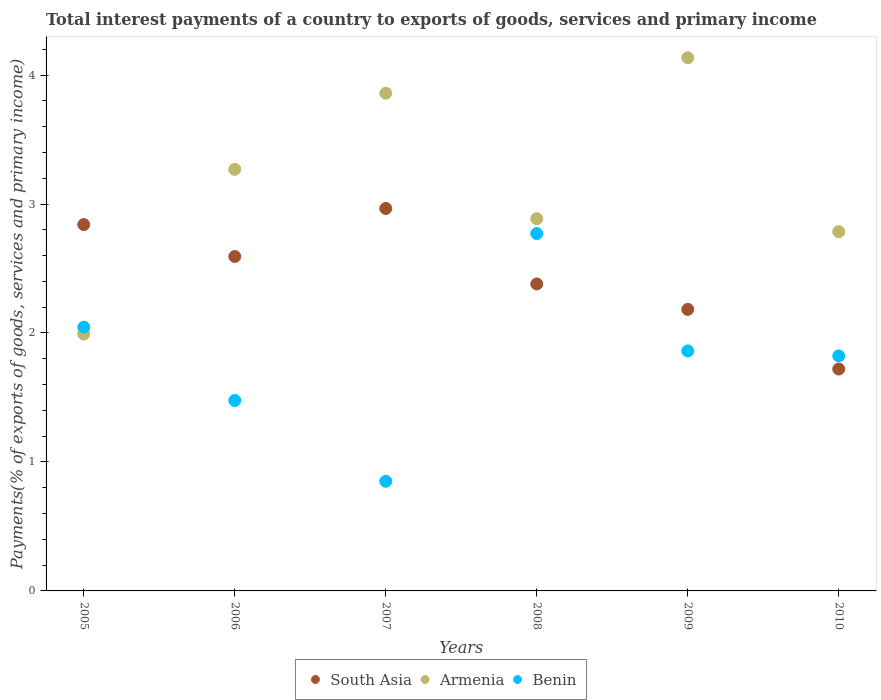What is the total interest payments in South Asia in 2006?
Provide a short and direct response. 2.59. Across all years, what is the maximum total interest payments in South Asia?
Give a very brief answer. 2.97. Across all years, what is the minimum total interest payments in Benin?
Provide a short and direct response. 0.85. In which year was the total interest payments in Armenia maximum?
Your answer should be compact. 2009. In which year was the total interest payments in Benin minimum?
Offer a very short reply. 2007. What is the total total interest payments in South Asia in the graph?
Provide a short and direct response. 14.68. What is the difference between the total interest payments in South Asia in 2009 and that in 2010?
Your answer should be very brief. 0.46. What is the difference between the total interest payments in South Asia in 2006 and the total interest payments in Benin in 2007?
Make the answer very short. 1.74. What is the average total interest payments in South Asia per year?
Provide a short and direct response. 2.45. In the year 2008, what is the difference between the total interest payments in South Asia and total interest payments in Benin?
Ensure brevity in your answer.  -0.39. What is the ratio of the total interest payments in Armenia in 2007 to that in 2010?
Give a very brief answer. 1.39. Is the total interest payments in Armenia in 2006 less than that in 2008?
Offer a very short reply. No. What is the difference between the highest and the second highest total interest payments in Benin?
Provide a short and direct response. 0.73. What is the difference between the highest and the lowest total interest payments in South Asia?
Give a very brief answer. 1.25. In how many years, is the total interest payments in Armenia greater than the average total interest payments in Armenia taken over all years?
Offer a very short reply. 3. Is the sum of the total interest payments in Benin in 2007 and 2008 greater than the maximum total interest payments in Armenia across all years?
Your answer should be very brief. No. Is it the case that in every year, the sum of the total interest payments in Benin and total interest payments in Armenia  is greater than the total interest payments in South Asia?
Provide a succinct answer. Yes. Is the total interest payments in South Asia strictly greater than the total interest payments in Armenia over the years?
Provide a short and direct response. No. How many dotlines are there?
Your answer should be very brief. 3. How many years are there in the graph?
Provide a short and direct response. 6. Are the values on the major ticks of Y-axis written in scientific E-notation?
Your answer should be very brief. No. Does the graph contain any zero values?
Your answer should be compact. No. How are the legend labels stacked?
Offer a terse response. Horizontal. What is the title of the graph?
Offer a very short reply. Total interest payments of a country to exports of goods, services and primary income. Does "Zambia" appear as one of the legend labels in the graph?
Your response must be concise. No. What is the label or title of the X-axis?
Give a very brief answer. Years. What is the label or title of the Y-axis?
Provide a short and direct response. Payments(% of exports of goods, services and primary income). What is the Payments(% of exports of goods, services and primary income) in South Asia in 2005?
Your answer should be very brief. 2.84. What is the Payments(% of exports of goods, services and primary income) of Armenia in 2005?
Offer a terse response. 1.99. What is the Payments(% of exports of goods, services and primary income) of Benin in 2005?
Your response must be concise. 2.05. What is the Payments(% of exports of goods, services and primary income) of South Asia in 2006?
Provide a short and direct response. 2.59. What is the Payments(% of exports of goods, services and primary income) in Armenia in 2006?
Offer a terse response. 3.27. What is the Payments(% of exports of goods, services and primary income) of Benin in 2006?
Provide a succinct answer. 1.48. What is the Payments(% of exports of goods, services and primary income) in South Asia in 2007?
Ensure brevity in your answer.  2.97. What is the Payments(% of exports of goods, services and primary income) of Armenia in 2007?
Offer a terse response. 3.86. What is the Payments(% of exports of goods, services and primary income) in Benin in 2007?
Your answer should be very brief. 0.85. What is the Payments(% of exports of goods, services and primary income) of South Asia in 2008?
Keep it short and to the point. 2.38. What is the Payments(% of exports of goods, services and primary income) in Armenia in 2008?
Offer a terse response. 2.89. What is the Payments(% of exports of goods, services and primary income) of Benin in 2008?
Provide a short and direct response. 2.77. What is the Payments(% of exports of goods, services and primary income) of South Asia in 2009?
Your response must be concise. 2.18. What is the Payments(% of exports of goods, services and primary income) of Armenia in 2009?
Provide a short and direct response. 4.13. What is the Payments(% of exports of goods, services and primary income) in Benin in 2009?
Your answer should be very brief. 1.86. What is the Payments(% of exports of goods, services and primary income) of South Asia in 2010?
Give a very brief answer. 1.72. What is the Payments(% of exports of goods, services and primary income) in Armenia in 2010?
Give a very brief answer. 2.79. What is the Payments(% of exports of goods, services and primary income) in Benin in 2010?
Make the answer very short. 1.82. Across all years, what is the maximum Payments(% of exports of goods, services and primary income) in South Asia?
Keep it short and to the point. 2.97. Across all years, what is the maximum Payments(% of exports of goods, services and primary income) of Armenia?
Provide a short and direct response. 4.13. Across all years, what is the maximum Payments(% of exports of goods, services and primary income) of Benin?
Your answer should be very brief. 2.77. Across all years, what is the minimum Payments(% of exports of goods, services and primary income) of South Asia?
Offer a terse response. 1.72. Across all years, what is the minimum Payments(% of exports of goods, services and primary income) of Armenia?
Ensure brevity in your answer.  1.99. Across all years, what is the minimum Payments(% of exports of goods, services and primary income) in Benin?
Your answer should be very brief. 0.85. What is the total Payments(% of exports of goods, services and primary income) in South Asia in the graph?
Your answer should be compact. 14.68. What is the total Payments(% of exports of goods, services and primary income) in Armenia in the graph?
Provide a succinct answer. 18.93. What is the total Payments(% of exports of goods, services and primary income) of Benin in the graph?
Offer a very short reply. 10.83. What is the difference between the Payments(% of exports of goods, services and primary income) in South Asia in 2005 and that in 2006?
Your answer should be compact. 0.25. What is the difference between the Payments(% of exports of goods, services and primary income) of Armenia in 2005 and that in 2006?
Your response must be concise. -1.28. What is the difference between the Payments(% of exports of goods, services and primary income) in Benin in 2005 and that in 2006?
Your answer should be very brief. 0.57. What is the difference between the Payments(% of exports of goods, services and primary income) in South Asia in 2005 and that in 2007?
Offer a very short reply. -0.12. What is the difference between the Payments(% of exports of goods, services and primary income) in Armenia in 2005 and that in 2007?
Your answer should be compact. -1.87. What is the difference between the Payments(% of exports of goods, services and primary income) of Benin in 2005 and that in 2007?
Ensure brevity in your answer.  1.19. What is the difference between the Payments(% of exports of goods, services and primary income) of South Asia in 2005 and that in 2008?
Provide a short and direct response. 0.46. What is the difference between the Payments(% of exports of goods, services and primary income) of Armenia in 2005 and that in 2008?
Provide a short and direct response. -0.9. What is the difference between the Payments(% of exports of goods, services and primary income) in Benin in 2005 and that in 2008?
Provide a short and direct response. -0.73. What is the difference between the Payments(% of exports of goods, services and primary income) of South Asia in 2005 and that in 2009?
Provide a succinct answer. 0.66. What is the difference between the Payments(% of exports of goods, services and primary income) in Armenia in 2005 and that in 2009?
Keep it short and to the point. -2.14. What is the difference between the Payments(% of exports of goods, services and primary income) of Benin in 2005 and that in 2009?
Offer a very short reply. 0.18. What is the difference between the Payments(% of exports of goods, services and primary income) of South Asia in 2005 and that in 2010?
Your response must be concise. 1.12. What is the difference between the Payments(% of exports of goods, services and primary income) of Armenia in 2005 and that in 2010?
Offer a terse response. -0.79. What is the difference between the Payments(% of exports of goods, services and primary income) of Benin in 2005 and that in 2010?
Your answer should be very brief. 0.22. What is the difference between the Payments(% of exports of goods, services and primary income) of South Asia in 2006 and that in 2007?
Offer a very short reply. -0.37. What is the difference between the Payments(% of exports of goods, services and primary income) of Armenia in 2006 and that in 2007?
Provide a short and direct response. -0.59. What is the difference between the Payments(% of exports of goods, services and primary income) in Benin in 2006 and that in 2007?
Offer a terse response. 0.63. What is the difference between the Payments(% of exports of goods, services and primary income) in South Asia in 2006 and that in 2008?
Your answer should be very brief. 0.21. What is the difference between the Payments(% of exports of goods, services and primary income) in Armenia in 2006 and that in 2008?
Give a very brief answer. 0.38. What is the difference between the Payments(% of exports of goods, services and primary income) of Benin in 2006 and that in 2008?
Ensure brevity in your answer.  -1.29. What is the difference between the Payments(% of exports of goods, services and primary income) in South Asia in 2006 and that in 2009?
Offer a terse response. 0.41. What is the difference between the Payments(% of exports of goods, services and primary income) of Armenia in 2006 and that in 2009?
Offer a very short reply. -0.87. What is the difference between the Payments(% of exports of goods, services and primary income) in Benin in 2006 and that in 2009?
Keep it short and to the point. -0.38. What is the difference between the Payments(% of exports of goods, services and primary income) in South Asia in 2006 and that in 2010?
Provide a succinct answer. 0.87. What is the difference between the Payments(% of exports of goods, services and primary income) of Armenia in 2006 and that in 2010?
Keep it short and to the point. 0.48. What is the difference between the Payments(% of exports of goods, services and primary income) of Benin in 2006 and that in 2010?
Your response must be concise. -0.35. What is the difference between the Payments(% of exports of goods, services and primary income) in South Asia in 2007 and that in 2008?
Make the answer very short. 0.59. What is the difference between the Payments(% of exports of goods, services and primary income) of Armenia in 2007 and that in 2008?
Offer a terse response. 0.97. What is the difference between the Payments(% of exports of goods, services and primary income) in Benin in 2007 and that in 2008?
Provide a short and direct response. -1.92. What is the difference between the Payments(% of exports of goods, services and primary income) in South Asia in 2007 and that in 2009?
Offer a terse response. 0.78. What is the difference between the Payments(% of exports of goods, services and primary income) of Armenia in 2007 and that in 2009?
Your response must be concise. -0.28. What is the difference between the Payments(% of exports of goods, services and primary income) in Benin in 2007 and that in 2009?
Provide a succinct answer. -1.01. What is the difference between the Payments(% of exports of goods, services and primary income) of South Asia in 2007 and that in 2010?
Your answer should be very brief. 1.25. What is the difference between the Payments(% of exports of goods, services and primary income) of Armenia in 2007 and that in 2010?
Give a very brief answer. 1.07. What is the difference between the Payments(% of exports of goods, services and primary income) in Benin in 2007 and that in 2010?
Keep it short and to the point. -0.97. What is the difference between the Payments(% of exports of goods, services and primary income) of South Asia in 2008 and that in 2009?
Your answer should be compact. 0.2. What is the difference between the Payments(% of exports of goods, services and primary income) of Armenia in 2008 and that in 2009?
Give a very brief answer. -1.25. What is the difference between the Payments(% of exports of goods, services and primary income) of Benin in 2008 and that in 2009?
Your answer should be very brief. 0.91. What is the difference between the Payments(% of exports of goods, services and primary income) in South Asia in 2008 and that in 2010?
Give a very brief answer. 0.66. What is the difference between the Payments(% of exports of goods, services and primary income) in Armenia in 2008 and that in 2010?
Keep it short and to the point. 0.1. What is the difference between the Payments(% of exports of goods, services and primary income) of Benin in 2008 and that in 2010?
Offer a terse response. 0.95. What is the difference between the Payments(% of exports of goods, services and primary income) of South Asia in 2009 and that in 2010?
Offer a very short reply. 0.46. What is the difference between the Payments(% of exports of goods, services and primary income) in Armenia in 2009 and that in 2010?
Offer a terse response. 1.35. What is the difference between the Payments(% of exports of goods, services and primary income) of Benin in 2009 and that in 2010?
Provide a succinct answer. 0.04. What is the difference between the Payments(% of exports of goods, services and primary income) in South Asia in 2005 and the Payments(% of exports of goods, services and primary income) in Armenia in 2006?
Provide a succinct answer. -0.43. What is the difference between the Payments(% of exports of goods, services and primary income) of South Asia in 2005 and the Payments(% of exports of goods, services and primary income) of Benin in 2006?
Keep it short and to the point. 1.36. What is the difference between the Payments(% of exports of goods, services and primary income) in Armenia in 2005 and the Payments(% of exports of goods, services and primary income) in Benin in 2006?
Your answer should be compact. 0.51. What is the difference between the Payments(% of exports of goods, services and primary income) in South Asia in 2005 and the Payments(% of exports of goods, services and primary income) in Armenia in 2007?
Give a very brief answer. -1.02. What is the difference between the Payments(% of exports of goods, services and primary income) in South Asia in 2005 and the Payments(% of exports of goods, services and primary income) in Benin in 2007?
Keep it short and to the point. 1.99. What is the difference between the Payments(% of exports of goods, services and primary income) of Armenia in 2005 and the Payments(% of exports of goods, services and primary income) of Benin in 2007?
Your answer should be compact. 1.14. What is the difference between the Payments(% of exports of goods, services and primary income) of South Asia in 2005 and the Payments(% of exports of goods, services and primary income) of Armenia in 2008?
Offer a terse response. -0.05. What is the difference between the Payments(% of exports of goods, services and primary income) in South Asia in 2005 and the Payments(% of exports of goods, services and primary income) in Benin in 2008?
Your response must be concise. 0.07. What is the difference between the Payments(% of exports of goods, services and primary income) of Armenia in 2005 and the Payments(% of exports of goods, services and primary income) of Benin in 2008?
Make the answer very short. -0.78. What is the difference between the Payments(% of exports of goods, services and primary income) in South Asia in 2005 and the Payments(% of exports of goods, services and primary income) in Armenia in 2009?
Offer a terse response. -1.29. What is the difference between the Payments(% of exports of goods, services and primary income) in South Asia in 2005 and the Payments(% of exports of goods, services and primary income) in Benin in 2009?
Ensure brevity in your answer.  0.98. What is the difference between the Payments(% of exports of goods, services and primary income) in Armenia in 2005 and the Payments(% of exports of goods, services and primary income) in Benin in 2009?
Give a very brief answer. 0.13. What is the difference between the Payments(% of exports of goods, services and primary income) in South Asia in 2005 and the Payments(% of exports of goods, services and primary income) in Armenia in 2010?
Your answer should be compact. 0.05. What is the difference between the Payments(% of exports of goods, services and primary income) in South Asia in 2005 and the Payments(% of exports of goods, services and primary income) in Benin in 2010?
Keep it short and to the point. 1.02. What is the difference between the Payments(% of exports of goods, services and primary income) of Armenia in 2005 and the Payments(% of exports of goods, services and primary income) of Benin in 2010?
Offer a terse response. 0.17. What is the difference between the Payments(% of exports of goods, services and primary income) in South Asia in 2006 and the Payments(% of exports of goods, services and primary income) in Armenia in 2007?
Your answer should be very brief. -1.27. What is the difference between the Payments(% of exports of goods, services and primary income) of South Asia in 2006 and the Payments(% of exports of goods, services and primary income) of Benin in 2007?
Provide a short and direct response. 1.74. What is the difference between the Payments(% of exports of goods, services and primary income) of Armenia in 2006 and the Payments(% of exports of goods, services and primary income) of Benin in 2007?
Your answer should be very brief. 2.42. What is the difference between the Payments(% of exports of goods, services and primary income) of South Asia in 2006 and the Payments(% of exports of goods, services and primary income) of Armenia in 2008?
Give a very brief answer. -0.29. What is the difference between the Payments(% of exports of goods, services and primary income) of South Asia in 2006 and the Payments(% of exports of goods, services and primary income) of Benin in 2008?
Your answer should be very brief. -0.18. What is the difference between the Payments(% of exports of goods, services and primary income) in Armenia in 2006 and the Payments(% of exports of goods, services and primary income) in Benin in 2008?
Your answer should be very brief. 0.5. What is the difference between the Payments(% of exports of goods, services and primary income) in South Asia in 2006 and the Payments(% of exports of goods, services and primary income) in Armenia in 2009?
Offer a terse response. -1.54. What is the difference between the Payments(% of exports of goods, services and primary income) in South Asia in 2006 and the Payments(% of exports of goods, services and primary income) in Benin in 2009?
Keep it short and to the point. 0.73. What is the difference between the Payments(% of exports of goods, services and primary income) in Armenia in 2006 and the Payments(% of exports of goods, services and primary income) in Benin in 2009?
Your answer should be compact. 1.41. What is the difference between the Payments(% of exports of goods, services and primary income) of South Asia in 2006 and the Payments(% of exports of goods, services and primary income) of Armenia in 2010?
Your answer should be compact. -0.19. What is the difference between the Payments(% of exports of goods, services and primary income) in South Asia in 2006 and the Payments(% of exports of goods, services and primary income) in Benin in 2010?
Ensure brevity in your answer.  0.77. What is the difference between the Payments(% of exports of goods, services and primary income) in Armenia in 2006 and the Payments(% of exports of goods, services and primary income) in Benin in 2010?
Ensure brevity in your answer.  1.45. What is the difference between the Payments(% of exports of goods, services and primary income) of South Asia in 2007 and the Payments(% of exports of goods, services and primary income) of Armenia in 2008?
Make the answer very short. 0.08. What is the difference between the Payments(% of exports of goods, services and primary income) of South Asia in 2007 and the Payments(% of exports of goods, services and primary income) of Benin in 2008?
Provide a succinct answer. 0.19. What is the difference between the Payments(% of exports of goods, services and primary income) of Armenia in 2007 and the Payments(% of exports of goods, services and primary income) of Benin in 2008?
Provide a short and direct response. 1.09. What is the difference between the Payments(% of exports of goods, services and primary income) in South Asia in 2007 and the Payments(% of exports of goods, services and primary income) in Armenia in 2009?
Offer a very short reply. -1.17. What is the difference between the Payments(% of exports of goods, services and primary income) in South Asia in 2007 and the Payments(% of exports of goods, services and primary income) in Benin in 2009?
Make the answer very short. 1.1. What is the difference between the Payments(% of exports of goods, services and primary income) in Armenia in 2007 and the Payments(% of exports of goods, services and primary income) in Benin in 2009?
Provide a succinct answer. 2. What is the difference between the Payments(% of exports of goods, services and primary income) in South Asia in 2007 and the Payments(% of exports of goods, services and primary income) in Armenia in 2010?
Give a very brief answer. 0.18. What is the difference between the Payments(% of exports of goods, services and primary income) of South Asia in 2007 and the Payments(% of exports of goods, services and primary income) of Benin in 2010?
Your response must be concise. 1.14. What is the difference between the Payments(% of exports of goods, services and primary income) in Armenia in 2007 and the Payments(% of exports of goods, services and primary income) in Benin in 2010?
Offer a very short reply. 2.04. What is the difference between the Payments(% of exports of goods, services and primary income) of South Asia in 2008 and the Payments(% of exports of goods, services and primary income) of Armenia in 2009?
Ensure brevity in your answer.  -1.75. What is the difference between the Payments(% of exports of goods, services and primary income) in South Asia in 2008 and the Payments(% of exports of goods, services and primary income) in Benin in 2009?
Provide a succinct answer. 0.52. What is the difference between the Payments(% of exports of goods, services and primary income) in Armenia in 2008 and the Payments(% of exports of goods, services and primary income) in Benin in 2009?
Offer a terse response. 1.03. What is the difference between the Payments(% of exports of goods, services and primary income) in South Asia in 2008 and the Payments(% of exports of goods, services and primary income) in Armenia in 2010?
Provide a short and direct response. -0.41. What is the difference between the Payments(% of exports of goods, services and primary income) in South Asia in 2008 and the Payments(% of exports of goods, services and primary income) in Benin in 2010?
Keep it short and to the point. 0.56. What is the difference between the Payments(% of exports of goods, services and primary income) in Armenia in 2008 and the Payments(% of exports of goods, services and primary income) in Benin in 2010?
Your response must be concise. 1.06. What is the difference between the Payments(% of exports of goods, services and primary income) of South Asia in 2009 and the Payments(% of exports of goods, services and primary income) of Armenia in 2010?
Provide a short and direct response. -0.6. What is the difference between the Payments(% of exports of goods, services and primary income) of South Asia in 2009 and the Payments(% of exports of goods, services and primary income) of Benin in 2010?
Your response must be concise. 0.36. What is the difference between the Payments(% of exports of goods, services and primary income) of Armenia in 2009 and the Payments(% of exports of goods, services and primary income) of Benin in 2010?
Make the answer very short. 2.31. What is the average Payments(% of exports of goods, services and primary income) in South Asia per year?
Give a very brief answer. 2.45. What is the average Payments(% of exports of goods, services and primary income) in Armenia per year?
Give a very brief answer. 3.15. What is the average Payments(% of exports of goods, services and primary income) of Benin per year?
Ensure brevity in your answer.  1.8. In the year 2005, what is the difference between the Payments(% of exports of goods, services and primary income) in South Asia and Payments(% of exports of goods, services and primary income) in Armenia?
Your response must be concise. 0.85. In the year 2005, what is the difference between the Payments(% of exports of goods, services and primary income) of South Asia and Payments(% of exports of goods, services and primary income) of Benin?
Ensure brevity in your answer.  0.8. In the year 2005, what is the difference between the Payments(% of exports of goods, services and primary income) in Armenia and Payments(% of exports of goods, services and primary income) in Benin?
Your answer should be compact. -0.05. In the year 2006, what is the difference between the Payments(% of exports of goods, services and primary income) in South Asia and Payments(% of exports of goods, services and primary income) in Armenia?
Offer a terse response. -0.68. In the year 2006, what is the difference between the Payments(% of exports of goods, services and primary income) of South Asia and Payments(% of exports of goods, services and primary income) of Benin?
Give a very brief answer. 1.12. In the year 2006, what is the difference between the Payments(% of exports of goods, services and primary income) of Armenia and Payments(% of exports of goods, services and primary income) of Benin?
Your answer should be very brief. 1.79. In the year 2007, what is the difference between the Payments(% of exports of goods, services and primary income) of South Asia and Payments(% of exports of goods, services and primary income) of Armenia?
Offer a very short reply. -0.89. In the year 2007, what is the difference between the Payments(% of exports of goods, services and primary income) of South Asia and Payments(% of exports of goods, services and primary income) of Benin?
Offer a terse response. 2.12. In the year 2007, what is the difference between the Payments(% of exports of goods, services and primary income) of Armenia and Payments(% of exports of goods, services and primary income) of Benin?
Your answer should be compact. 3.01. In the year 2008, what is the difference between the Payments(% of exports of goods, services and primary income) in South Asia and Payments(% of exports of goods, services and primary income) in Armenia?
Your response must be concise. -0.51. In the year 2008, what is the difference between the Payments(% of exports of goods, services and primary income) of South Asia and Payments(% of exports of goods, services and primary income) of Benin?
Offer a very short reply. -0.39. In the year 2008, what is the difference between the Payments(% of exports of goods, services and primary income) of Armenia and Payments(% of exports of goods, services and primary income) of Benin?
Give a very brief answer. 0.12. In the year 2009, what is the difference between the Payments(% of exports of goods, services and primary income) of South Asia and Payments(% of exports of goods, services and primary income) of Armenia?
Your answer should be compact. -1.95. In the year 2009, what is the difference between the Payments(% of exports of goods, services and primary income) of South Asia and Payments(% of exports of goods, services and primary income) of Benin?
Your response must be concise. 0.32. In the year 2009, what is the difference between the Payments(% of exports of goods, services and primary income) of Armenia and Payments(% of exports of goods, services and primary income) of Benin?
Your answer should be compact. 2.27. In the year 2010, what is the difference between the Payments(% of exports of goods, services and primary income) in South Asia and Payments(% of exports of goods, services and primary income) in Armenia?
Provide a succinct answer. -1.07. In the year 2010, what is the difference between the Payments(% of exports of goods, services and primary income) of South Asia and Payments(% of exports of goods, services and primary income) of Benin?
Your response must be concise. -0.1. In the year 2010, what is the difference between the Payments(% of exports of goods, services and primary income) of Armenia and Payments(% of exports of goods, services and primary income) of Benin?
Your answer should be compact. 0.96. What is the ratio of the Payments(% of exports of goods, services and primary income) in South Asia in 2005 to that in 2006?
Provide a short and direct response. 1.1. What is the ratio of the Payments(% of exports of goods, services and primary income) of Armenia in 2005 to that in 2006?
Make the answer very short. 0.61. What is the ratio of the Payments(% of exports of goods, services and primary income) of Benin in 2005 to that in 2006?
Offer a very short reply. 1.38. What is the ratio of the Payments(% of exports of goods, services and primary income) of South Asia in 2005 to that in 2007?
Ensure brevity in your answer.  0.96. What is the ratio of the Payments(% of exports of goods, services and primary income) in Armenia in 2005 to that in 2007?
Provide a succinct answer. 0.52. What is the ratio of the Payments(% of exports of goods, services and primary income) of Benin in 2005 to that in 2007?
Your answer should be very brief. 2.4. What is the ratio of the Payments(% of exports of goods, services and primary income) in South Asia in 2005 to that in 2008?
Keep it short and to the point. 1.19. What is the ratio of the Payments(% of exports of goods, services and primary income) of Armenia in 2005 to that in 2008?
Ensure brevity in your answer.  0.69. What is the ratio of the Payments(% of exports of goods, services and primary income) of Benin in 2005 to that in 2008?
Provide a short and direct response. 0.74. What is the ratio of the Payments(% of exports of goods, services and primary income) of South Asia in 2005 to that in 2009?
Offer a terse response. 1.3. What is the ratio of the Payments(% of exports of goods, services and primary income) in Armenia in 2005 to that in 2009?
Your answer should be compact. 0.48. What is the ratio of the Payments(% of exports of goods, services and primary income) of Benin in 2005 to that in 2009?
Keep it short and to the point. 1.1. What is the ratio of the Payments(% of exports of goods, services and primary income) in South Asia in 2005 to that in 2010?
Provide a succinct answer. 1.65. What is the ratio of the Payments(% of exports of goods, services and primary income) in Armenia in 2005 to that in 2010?
Provide a short and direct response. 0.71. What is the ratio of the Payments(% of exports of goods, services and primary income) of Benin in 2005 to that in 2010?
Give a very brief answer. 1.12. What is the ratio of the Payments(% of exports of goods, services and primary income) in South Asia in 2006 to that in 2007?
Offer a very short reply. 0.87. What is the ratio of the Payments(% of exports of goods, services and primary income) in Armenia in 2006 to that in 2007?
Your answer should be very brief. 0.85. What is the ratio of the Payments(% of exports of goods, services and primary income) in Benin in 2006 to that in 2007?
Your response must be concise. 1.74. What is the ratio of the Payments(% of exports of goods, services and primary income) in South Asia in 2006 to that in 2008?
Your answer should be very brief. 1.09. What is the ratio of the Payments(% of exports of goods, services and primary income) in Armenia in 2006 to that in 2008?
Offer a terse response. 1.13. What is the ratio of the Payments(% of exports of goods, services and primary income) in Benin in 2006 to that in 2008?
Your answer should be compact. 0.53. What is the ratio of the Payments(% of exports of goods, services and primary income) in South Asia in 2006 to that in 2009?
Offer a terse response. 1.19. What is the ratio of the Payments(% of exports of goods, services and primary income) of Armenia in 2006 to that in 2009?
Offer a very short reply. 0.79. What is the ratio of the Payments(% of exports of goods, services and primary income) in Benin in 2006 to that in 2009?
Make the answer very short. 0.79. What is the ratio of the Payments(% of exports of goods, services and primary income) of South Asia in 2006 to that in 2010?
Provide a succinct answer. 1.51. What is the ratio of the Payments(% of exports of goods, services and primary income) of Armenia in 2006 to that in 2010?
Ensure brevity in your answer.  1.17. What is the ratio of the Payments(% of exports of goods, services and primary income) of Benin in 2006 to that in 2010?
Make the answer very short. 0.81. What is the ratio of the Payments(% of exports of goods, services and primary income) in South Asia in 2007 to that in 2008?
Make the answer very short. 1.25. What is the ratio of the Payments(% of exports of goods, services and primary income) of Armenia in 2007 to that in 2008?
Offer a terse response. 1.34. What is the ratio of the Payments(% of exports of goods, services and primary income) in Benin in 2007 to that in 2008?
Keep it short and to the point. 0.31. What is the ratio of the Payments(% of exports of goods, services and primary income) in South Asia in 2007 to that in 2009?
Provide a succinct answer. 1.36. What is the ratio of the Payments(% of exports of goods, services and primary income) of Armenia in 2007 to that in 2009?
Your response must be concise. 0.93. What is the ratio of the Payments(% of exports of goods, services and primary income) in Benin in 2007 to that in 2009?
Your answer should be compact. 0.46. What is the ratio of the Payments(% of exports of goods, services and primary income) of South Asia in 2007 to that in 2010?
Provide a short and direct response. 1.72. What is the ratio of the Payments(% of exports of goods, services and primary income) in Armenia in 2007 to that in 2010?
Keep it short and to the point. 1.39. What is the ratio of the Payments(% of exports of goods, services and primary income) of Benin in 2007 to that in 2010?
Ensure brevity in your answer.  0.47. What is the ratio of the Payments(% of exports of goods, services and primary income) of South Asia in 2008 to that in 2009?
Your answer should be compact. 1.09. What is the ratio of the Payments(% of exports of goods, services and primary income) in Armenia in 2008 to that in 2009?
Ensure brevity in your answer.  0.7. What is the ratio of the Payments(% of exports of goods, services and primary income) in Benin in 2008 to that in 2009?
Make the answer very short. 1.49. What is the ratio of the Payments(% of exports of goods, services and primary income) in South Asia in 2008 to that in 2010?
Give a very brief answer. 1.38. What is the ratio of the Payments(% of exports of goods, services and primary income) of Armenia in 2008 to that in 2010?
Your response must be concise. 1.04. What is the ratio of the Payments(% of exports of goods, services and primary income) in Benin in 2008 to that in 2010?
Give a very brief answer. 1.52. What is the ratio of the Payments(% of exports of goods, services and primary income) in South Asia in 2009 to that in 2010?
Provide a succinct answer. 1.27. What is the ratio of the Payments(% of exports of goods, services and primary income) in Armenia in 2009 to that in 2010?
Your answer should be compact. 1.48. What is the ratio of the Payments(% of exports of goods, services and primary income) of Benin in 2009 to that in 2010?
Offer a terse response. 1.02. What is the difference between the highest and the second highest Payments(% of exports of goods, services and primary income) in Armenia?
Your answer should be compact. 0.28. What is the difference between the highest and the second highest Payments(% of exports of goods, services and primary income) in Benin?
Your answer should be compact. 0.73. What is the difference between the highest and the lowest Payments(% of exports of goods, services and primary income) in South Asia?
Offer a terse response. 1.25. What is the difference between the highest and the lowest Payments(% of exports of goods, services and primary income) of Armenia?
Give a very brief answer. 2.14. What is the difference between the highest and the lowest Payments(% of exports of goods, services and primary income) of Benin?
Offer a very short reply. 1.92. 